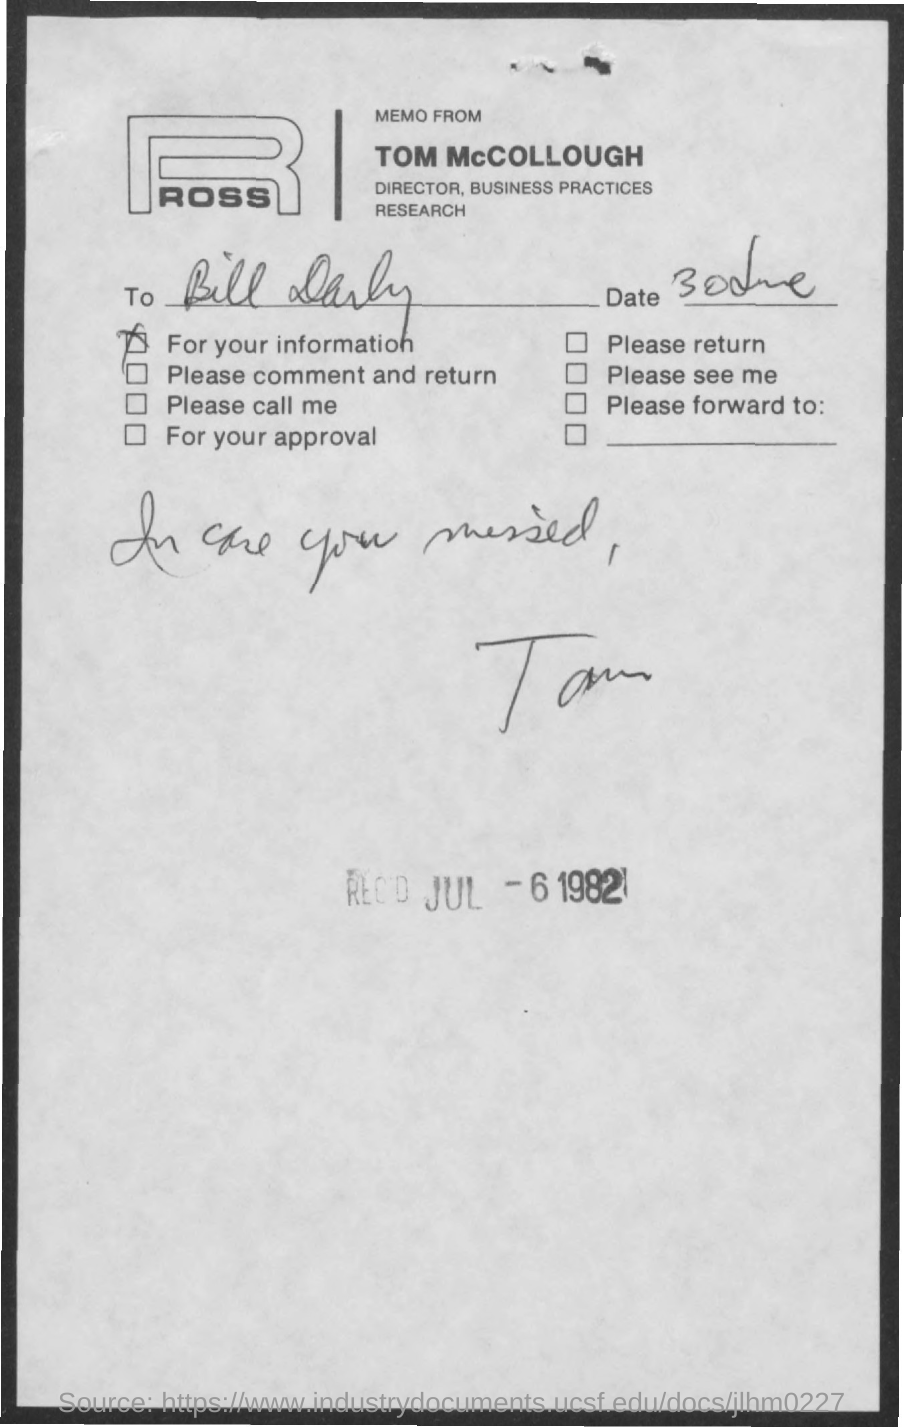Who is the sender of this memo?
Give a very brief answer. TOM MCCOLLOUGH. What is the designation of TOM McCOLLOUGH?
Offer a very short reply. DIRECTOR, BUSINESS PRACTICES RESEARCH. To whom, the memo is addressed?
Provide a succinct answer. Bill Darby. What is the received date stamped?
Your answer should be very brief. JUL-6 1982. 